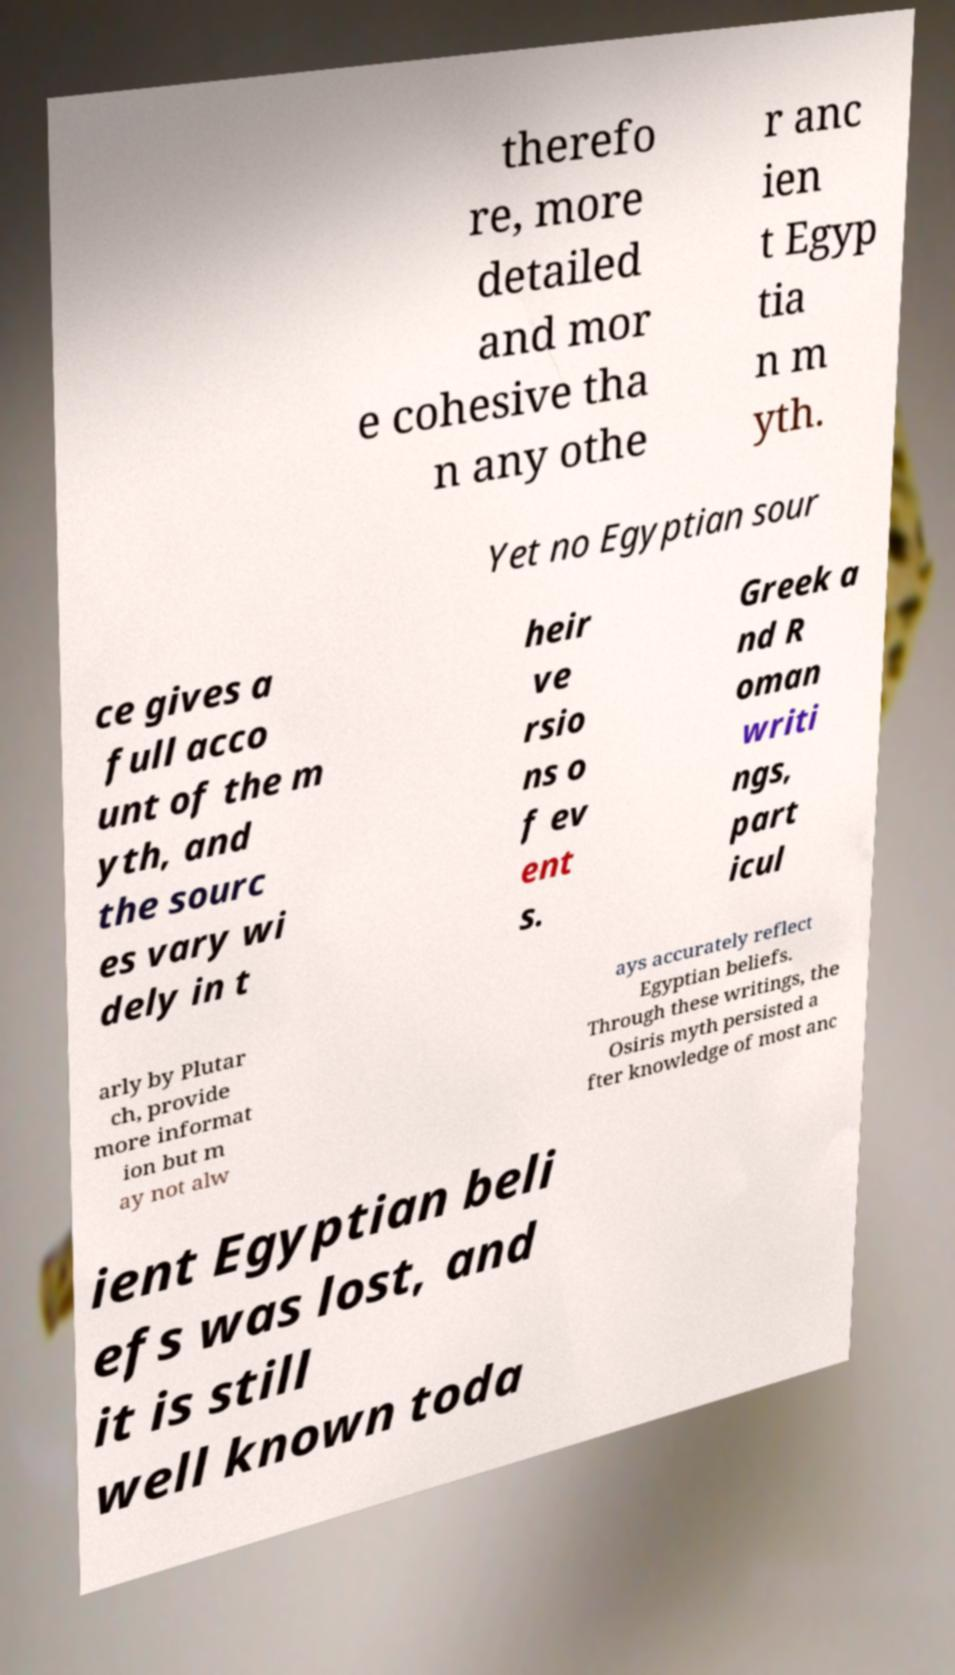Can you accurately transcribe the text from the provided image for me? therefo re, more detailed and mor e cohesive tha n any othe r anc ien t Egyp tia n m yth. Yet no Egyptian sour ce gives a full acco unt of the m yth, and the sourc es vary wi dely in t heir ve rsio ns o f ev ent s. Greek a nd R oman writi ngs, part icul arly by Plutar ch, provide more informat ion but m ay not alw ays accurately reflect Egyptian beliefs. Through these writings, the Osiris myth persisted a fter knowledge of most anc ient Egyptian beli efs was lost, and it is still well known toda 